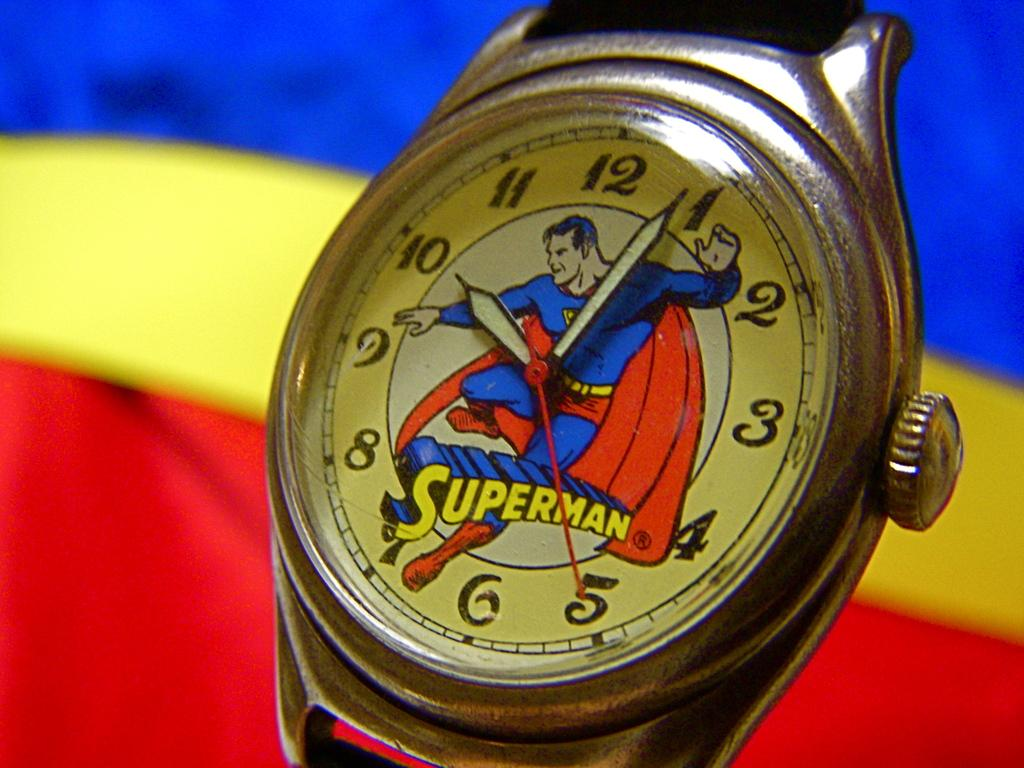Provide a one-sentence caption for the provided image. A Superman watch showing that it is 10:04. 